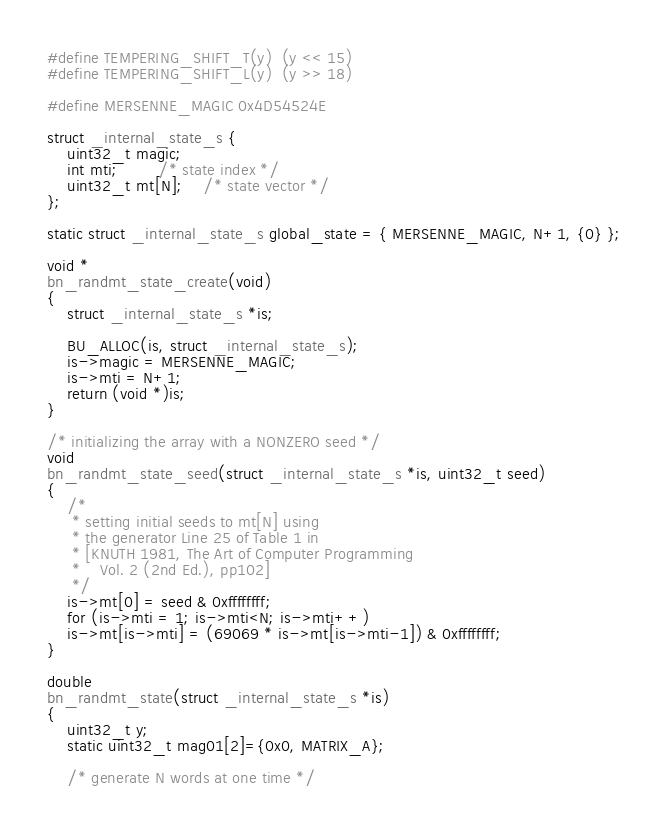Convert code to text. <code><loc_0><loc_0><loc_500><loc_500><_C_>#define TEMPERING_SHIFT_T(y)  (y << 15)
#define TEMPERING_SHIFT_L(y)  (y >> 18)

#define MERSENNE_MAGIC 0x4D54524E

struct _internal_state_s {
    uint32_t magic;
    int mti;		/* state index */
    uint32_t mt[N];	/* state vector */
};

static struct _internal_state_s global_state = { MERSENNE_MAGIC, N+1, {0} };

void *
bn_randmt_state_create(void)
{
    struct _internal_state_s *is;

    BU_ALLOC(is, struct _internal_state_s);
    is->magic = MERSENNE_MAGIC;
    is->mti = N+1;
    return (void *)is;
}

/* initializing the array with a NONZERO seed */
void
bn_randmt_state_seed(struct _internal_state_s *is, uint32_t seed)
{
    /*
     * setting initial seeds to mt[N] using
     * the generator Line 25 of Table 1 in
     * [KNUTH 1981, The Art of Computer Programming
     *    Vol. 2 (2nd Ed.), pp102]
     */
    is->mt[0] = seed & 0xffffffff;
    for (is->mti = 1; is->mti<N; is->mti++)
	is->mt[is->mti] = (69069 * is->mt[is->mti-1]) & 0xffffffff;
}

double
bn_randmt_state(struct _internal_state_s *is)
{
    uint32_t y;
    static uint32_t mag01[2]={0x0, MATRIX_A};

    /* generate N words at one time */</code> 